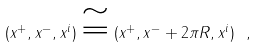Convert formula to latex. <formula><loc_0><loc_0><loc_500><loc_500>( x ^ { + } , x ^ { - } , x ^ { i } ) \cong ( x ^ { + } , x ^ { - } + 2 \pi R , x ^ { i } ) \ ,</formula> 